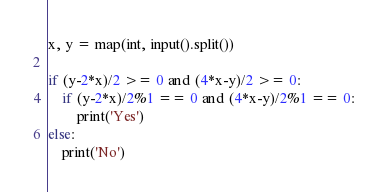<code> <loc_0><loc_0><loc_500><loc_500><_Python_>x, y = map(int, input().split())

if (y-2*x)/2 >= 0 and (4*x-y)/2 >= 0:
	if (y-2*x)/2%1 == 0 and (4*x-y)/2%1 == 0:
		print('Yes')
else:
	print('No')</code> 